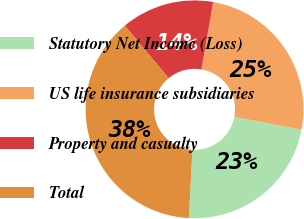Convert chart. <chart><loc_0><loc_0><loc_500><loc_500><pie_chart><fcel>Statutory Net Income (Loss)<fcel>US life insurance subsidiaries<fcel>Property and casualty<fcel>Total<nl><fcel>22.83%<fcel>25.26%<fcel>13.8%<fcel>38.11%<nl></chart> 